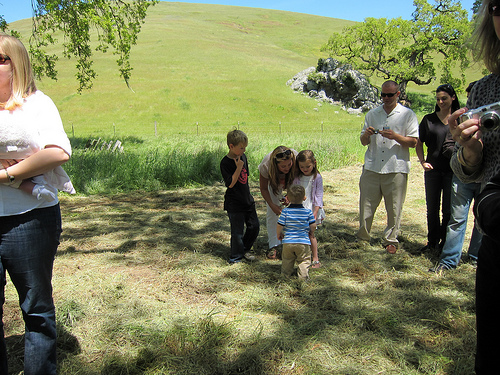<image>
Is the grass on the land? Yes. Looking at the image, I can see the grass is positioned on top of the land, with the land providing support. Is the person above the grass? No. The person is not positioned above the grass. The vertical arrangement shows a different relationship. 